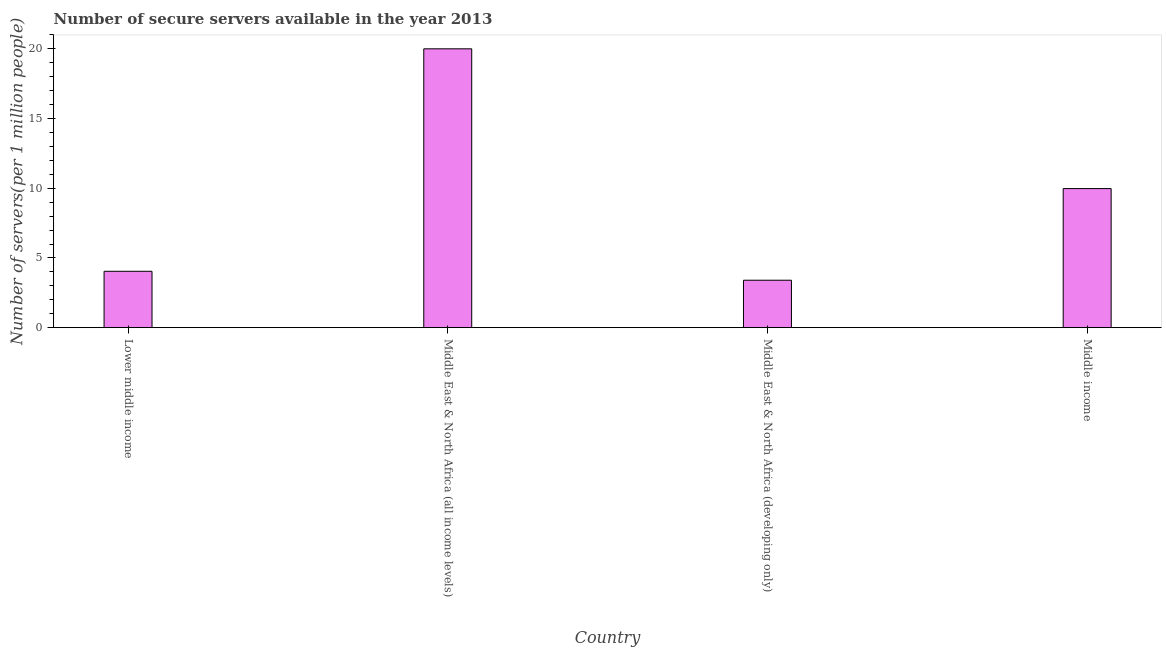Does the graph contain any zero values?
Offer a terse response. No. What is the title of the graph?
Your response must be concise. Number of secure servers available in the year 2013. What is the label or title of the X-axis?
Offer a very short reply. Country. What is the label or title of the Y-axis?
Offer a terse response. Number of servers(per 1 million people). What is the number of secure internet servers in Middle East & North Africa (all income levels)?
Keep it short and to the point. 20. Across all countries, what is the maximum number of secure internet servers?
Keep it short and to the point. 20. Across all countries, what is the minimum number of secure internet servers?
Provide a short and direct response. 3.4. In which country was the number of secure internet servers maximum?
Provide a short and direct response. Middle East & North Africa (all income levels). In which country was the number of secure internet servers minimum?
Give a very brief answer. Middle East & North Africa (developing only). What is the sum of the number of secure internet servers?
Offer a terse response. 37.42. What is the difference between the number of secure internet servers in Middle East & North Africa (all income levels) and Middle East & North Africa (developing only)?
Your answer should be very brief. 16.6. What is the average number of secure internet servers per country?
Your answer should be compact. 9.36. What is the median number of secure internet servers?
Keep it short and to the point. 7.01. What is the ratio of the number of secure internet servers in Lower middle income to that in Middle East & North Africa (all income levels)?
Ensure brevity in your answer.  0.2. What is the difference between the highest and the second highest number of secure internet servers?
Provide a short and direct response. 10.03. Is the sum of the number of secure internet servers in Middle East & North Africa (developing only) and Middle income greater than the maximum number of secure internet servers across all countries?
Your response must be concise. No. What is the difference between the highest and the lowest number of secure internet servers?
Your answer should be compact. 16.6. Are all the bars in the graph horizontal?
Give a very brief answer. No. How many countries are there in the graph?
Provide a succinct answer. 4. What is the Number of servers(per 1 million people) of Lower middle income?
Offer a very short reply. 4.04. What is the Number of servers(per 1 million people) in Middle East & North Africa (all income levels)?
Offer a terse response. 20. What is the Number of servers(per 1 million people) of Middle East & North Africa (developing only)?
Your response must be concise. 3.4. What is the Number of servers(per 1 million people) of Middle income?
Make the answer very short. 9.98. What is the difference between the Number of servers(per 1 million people) in Lower middle income and Middle East & North Africa (all income levels)?
Make the answer very short. -15.96. What is the difference between the Number of servers(per 1 million people) in Lower middle income and Middle East & North Africa (developing only)?
Make the answer very short. 0.64. What is the difference between the Number of servers(per 1 million people) in Lower middle income and Middle income?
Make the answer very short. -5.93. What is the difference between the Number of servers(per 1 million people) in Middle East & North Africa (all income levels) and Middle East & North Africa (developing only)?
Your answer should be compact. 16.6. What is the difference between the Number of servers(per 1 million people) in Middle East & North Africa (all income levels) and Middle income?
Keep it short and to the point. 10.03. What is the difference between the Number of servers(per 1 million people) in Middle East & North Africa (developing only) and Middle income?
Make the answer very short. -6.57. What is the ratio of the Number of servers(per 1 million people) in Lower middle income to that in Middle East & North Africa (all income levels)?
Keep it short and to the point. 0.2. What is the ratio of the Number of servers(per 1 million people) in Lower middle income to that in Middle East & North Africa (developing only)?
Your answer should be compact. 1.19. What is the ratio of the Number of servers(per 1 million people) in Lower middle income to that in Middle income?
Your answer should be compact. 0.41. What is the ratio of the Number of servers(per 1 million people) in Middle East & North Africa (all income levels) to that in Middle East & North Africa (developing only)?
Your answer should be compact. 5.88. What is the ratio of the Number of servers(per 1 million people) in Middle East & North Africa (all income levels) to that in Middle income?
Give a very brief answer. 2. What is the ratio of the Number of servers(per 1 million people) in Middle East & North Africa (developing only) to that in Middle income?
Provide a succinct answer. 0.34. 